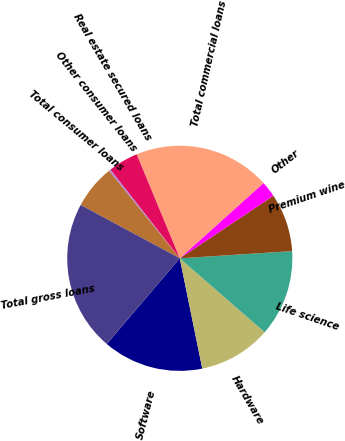<chart> <loc_0><loc_0><loc_500><loc_500><pie_chart><fcel>Software<fcel>Hardware<fcel>Life science<fcel>Premium wine<fcel>Other<fcel>Total commercial loans<fcel>Real estate secured loans<fcel>Other consumer loans<fcel>Total consumer loans<fcel>Total gross loans<nl><fcel>14.44%<fcel>10.39%<fcel>12.42%<fcel>8.36%<fcel>2.28%<fcel>19.6%<fcel>4.31%<fcel>0.25%<fcel>6.33%<fcel>21.62%<nl></chart> 